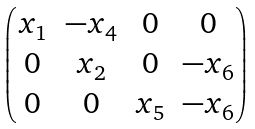Convert formula to latex. <formula><loc_0><loc_0><loc_500><loc_500>\begin{pmatrix} x _ { 1 } & - x _ { 4 } & 0 & 0 \\ 0 & x _ { 2 } & 0 & - x _ { 6 } \\ 0 & 0 & x _ { 5 } & - x _ { 6 } \end{pmatrix}</formula> 